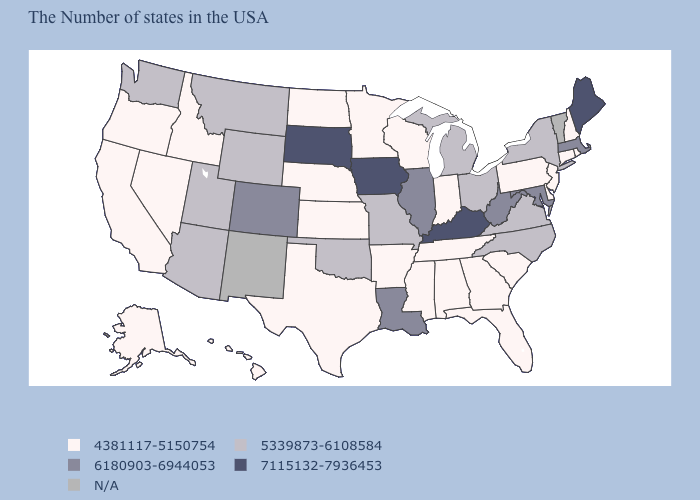Does the map have missing data?
Answer briefly. Yes. What is the highest value in states that border Wyoming?
Be succinct. 7115132-7936453. What is the value of West Virginia?
Answer briefly. 6180903-6944053. Name the states that have a value in the range 7115132-7936453?
Write a very short answer. Maine, Kentucky, Iowa, South Dakota. What is the value of Wyoming?
Short answer required. 5339873-6108584. Does Maine have the highest value in the USA?
Give a very brief answer. Yes. Name the states that have a value in the range 4381117-5150754?
Quick response, please. Rhode Island, New Hampshire, Connecticut, New Jersey, Delaware, Pennsylvania, South Carolina, Florida, Georgia, Indiana, Alabama, Tennessee, Wisconsin, Mississippi, Arkansas, Minnesota, Kansas, Nebraska, Texas, North Dakota, Idaho, Nevada, California, Oregon, Alaska, Hawaii. Name the states that have a value in the range 6180903-6944053?
Give a very brief answer. Massachusetts, Maryland, West Virginia, Illinois, Louisiana, Colorado. Among the states that border Kansas , does Nebraska have the highest value?
Concise answer only. No. What is the lowest value in states that border Kentucky?
Give a very brief answer. 4381117-5150754. Name the states that have a value in the range 5339873-6108584?
Short answer required. New York, Virginia, North Carolina, Ohio, Michigan, Missouri, Oklahoma, Wyoming, Utah, Montana, Arizona, Washington. Name the states that have a value in the range 7115132-7936453?
Keep it brief. Maine, Kentucky, Iowa, South Dakota. Which states have the lowest value in the USA?
Answer briefly. Rhode Island, New Hampshire, Connecticut, New Jersey, Delaware, Pennsylvania, South Carolina, Florida, Georgia, Indiana, Alabama, Tennessee, Wisconsin, Mississippi, Arkansas, Minnesota, Kansas, Nebraska, Texas, North Dakota, Idaho, Nevada, California, Oregon, Alaska, Hawaii. 